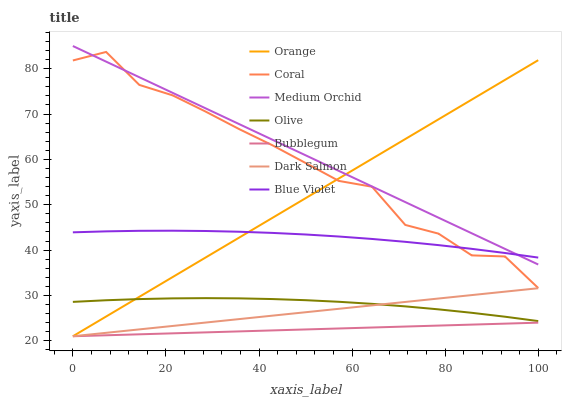Does Bubblegum have the minimum area under the curve?
Answer yes or no. Yes. Does Medium Orchid have the maximum area under the curve?
Answer yes or no. Yes. Does Dark Salmon have the minimum area under the curve?
Answer yes or no. No. Does Dark Salmon have the maximum area under the curve?
Answer yes or no. No. Is Dark Salmon the smoothest?
Answer yes or no. Yes. Is Coral the roughest?
Answer yes or no. Yes. Is Medium Orchid the smoothest?
Answer yes or no. No. Is Medium Orchid the roughest?
Answer yes or no. No. Does Medium Orchid have the lowest value?
Answer yes or no. No. Does Medium Orchid have the highest value?
Answer yes or no. Yes. Does Dark Salmon have the highest value?
Answer yes or no. No. Is Bubblegum less than Blue Violet?
Answer yes or no. Yes. Is Olive greater than Bubblegum?
Answer yes or no. Yes. Does Dark Salmon intersect Olive?
Answer yes or no. Yes. Is Dark Salmon less than Olive?
Answer yes or no. No. Is Dark Salmon greater than Olive?
Answer yes or no. No. Does Bubblegum intersect Blue Violet?
Answer yes or no. No. 